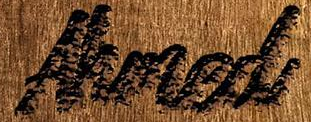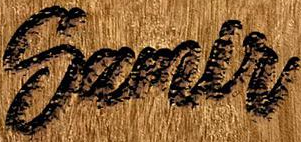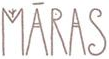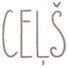What words are shown in these images in order, separated by a semicolon? Ahmed; Samlr; MĀRAS; CEḶŠ 